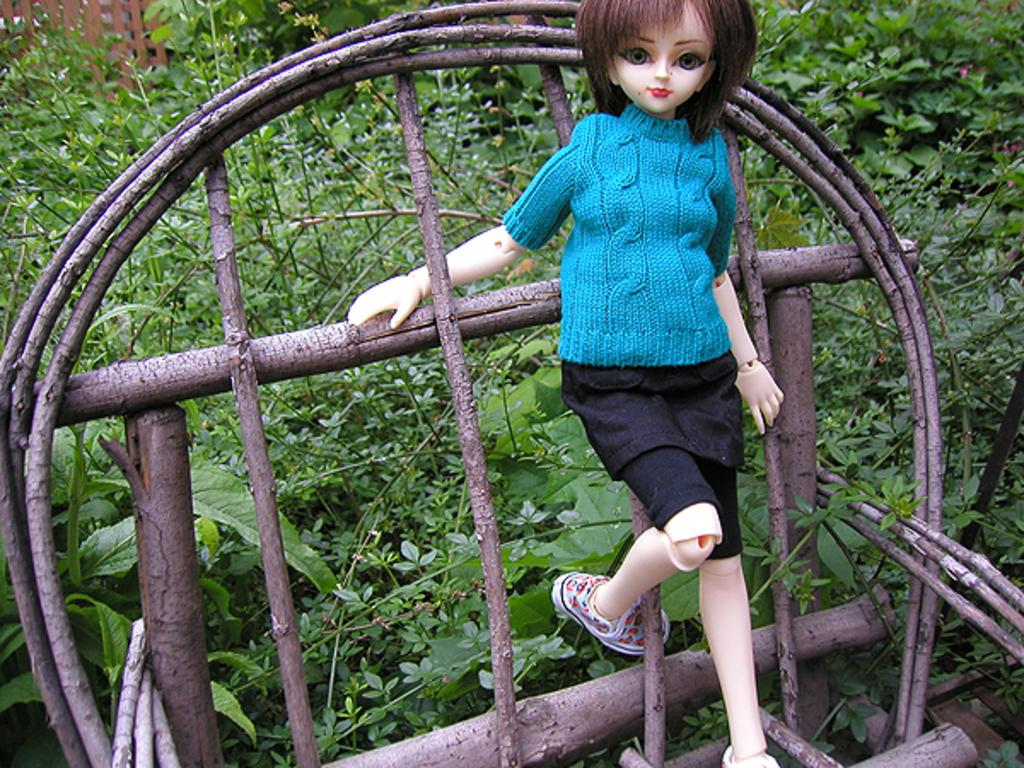What object in the image is designed for play or amusement? There is a toy in the image. What type of vegetation can be seen in the image? There are plants and bushes in the image. What material is used to make the sticks in the image? The sticks in the image are made of wood. What structure is present in the image to separate or enclose an area? There is a fence in the image. What causes the toy to cough in the image? There is no coughing in the image, as it is a toy and does not have the ability to cough. How does the fear of the plants manifest in the image? There is no fear present in the image, as the plants are not threatening or causing any negative emotions. 